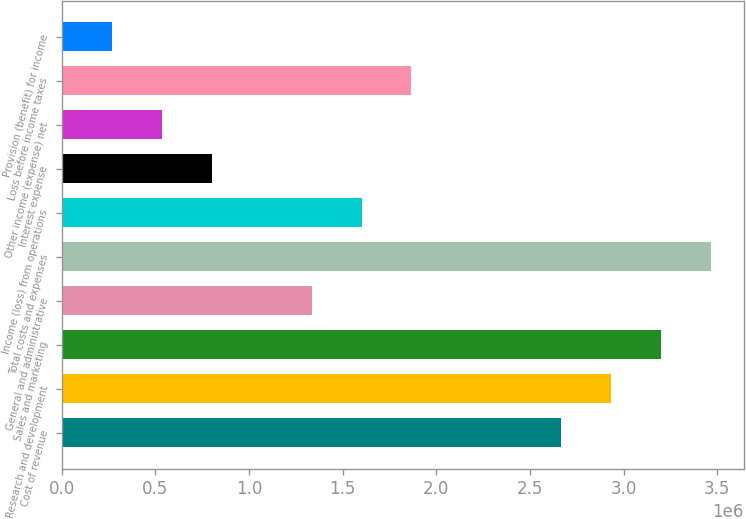Convert chart. <chart><loc_0><loc_0><loc_500><loc_500><bar_chart><fcel>Cost of revenue<fcel>Research and development<fcel>Sales and marketing<fcel>General and administrative<fcel>Total costs and expenses<fcel>Income (loss) from operations<fcel>Interest expense<fcel>Other income (expense) net<fcel>Loss before income taxes<fcel>Provision (benefit) for income<nl><fcel>2.66807e+06<fcel>2.93487e+06<fcel>3.20168e+06<fcel>1.33403e+06<fcel>3.46849e+06<fcel>1.60084e+06<fcel>800421<fcel>533614<fcel>1.86765e+06<fcel>266808<nl></chart> 